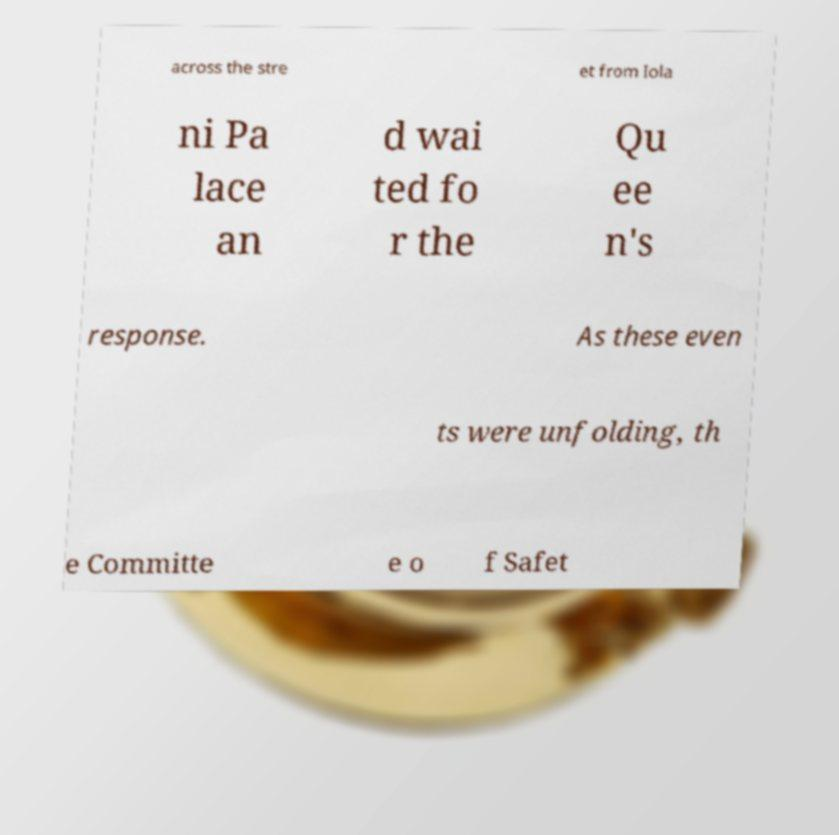Please identify and transcribe the text found in this image. across the stre et from Iola ni Pa lace an d wai ted fo r the Qu ee n's response. As these even ts were unfolding, th e Committe e o f Safet 